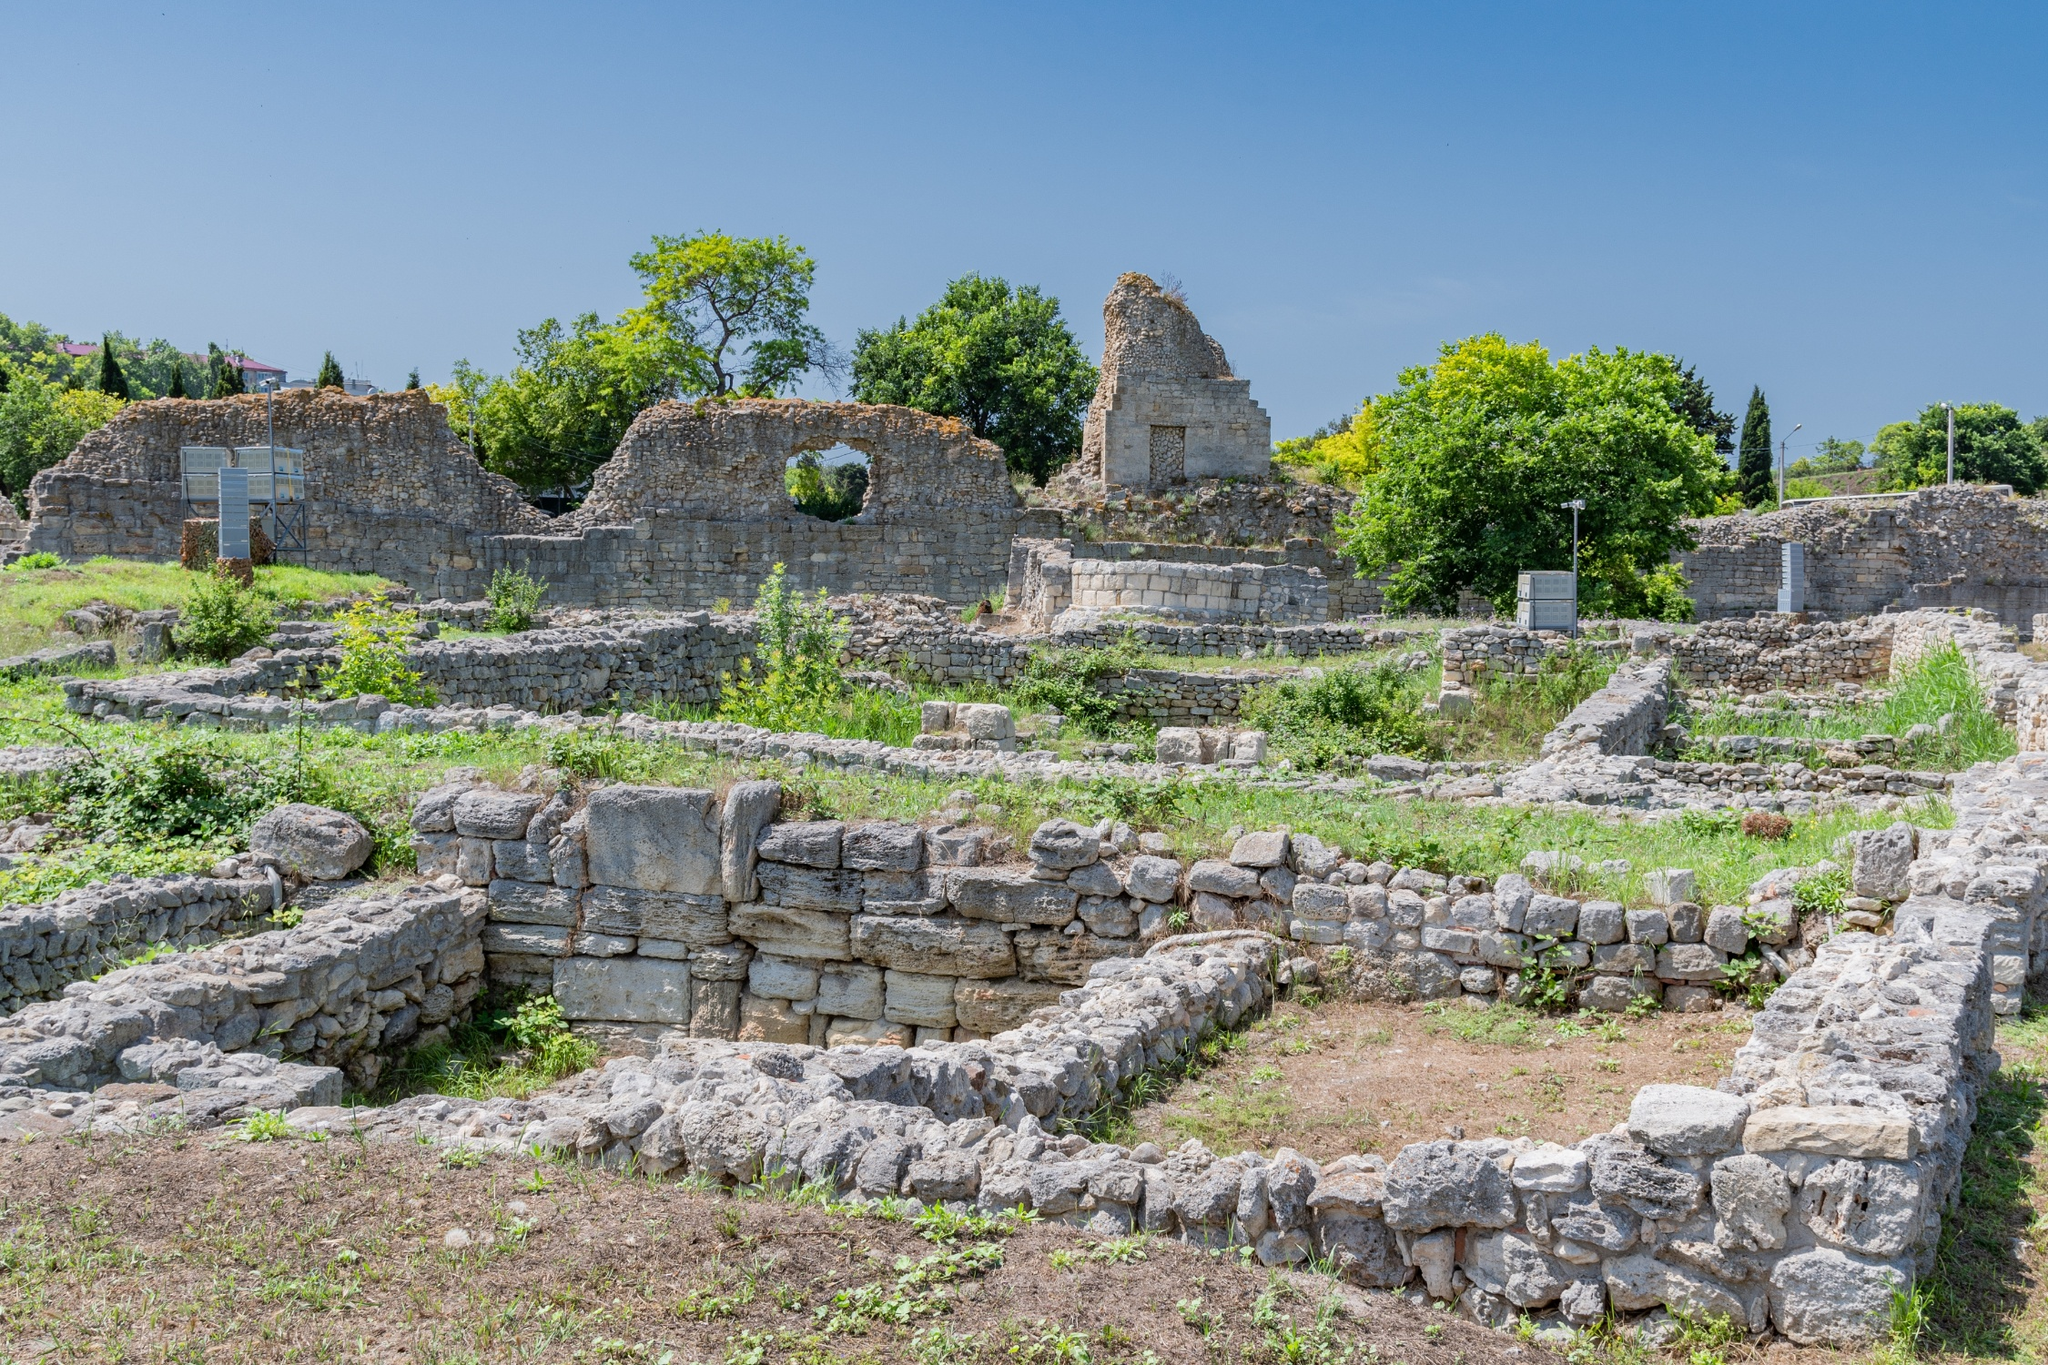Can you describe the surroundings of these ruins? Indeed! The ruins are enveloped in a lush landscape where nature seems to be reclaiming the land. In the vicinity of the ancient structures, there's a proliferation of green grass and various species of trees that offer a striking contrast against the gray stones. The grounds are uneven and dotted with remnants of walls and buildings, indicating a once-thriving civilization. Beyond the greenery and ruins, there's a cerulean blue sky with a few puffy clouds drifting lazily through the air, creating a tranquil and reflective atmosphere. What do you think life was like in this ancient city? Life in this ancient city was likely bustling and vibrant. The careful urban planning suggested by the layout of the ruins points to an advanced society with a well-organized infrastructure. The large walls and structures imply that these buildings may have been used for significant activities such as governance, religious ceremonies, or trade. Markets would have been filled with vendors selling goods, while citizens engaged in daily routines, contributing to a dynamic economic and social life. The presence of a well-constructed doorway signals the importance of security and controlled access, indicating a society that valued order and protection. 